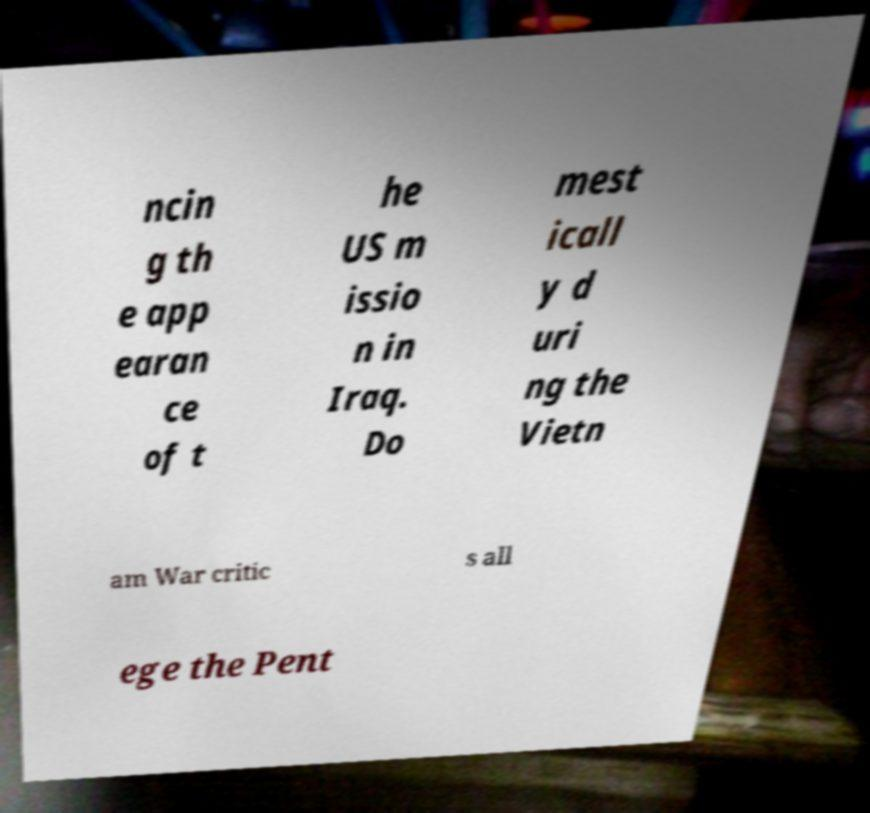What messages or text are displayed in this image? I need them in a readable, typed format. ncin g th e app earan ce of t he US m issio n in Iraq. Do mest icall y d uri ng the Vietn am War critic s all ege the Pent 